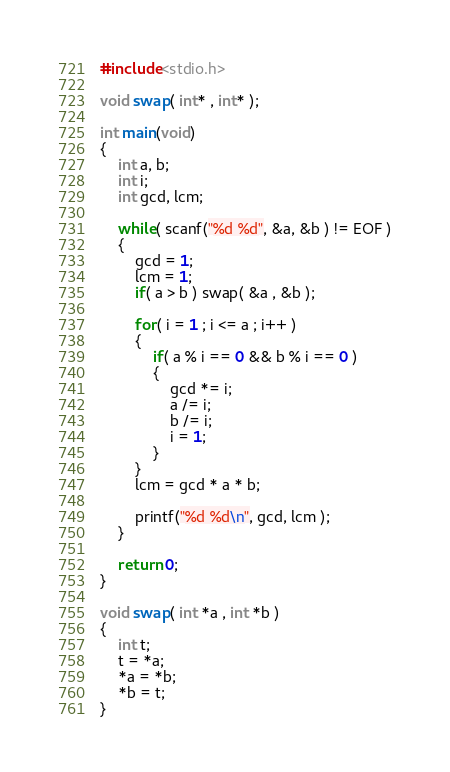<code> <loc_0><loc_0><loc_500><loc_500><_C_>#include<stdio.h>

void swap( int* , int* );

int main(void)
{
	int a, b;
	int i;
	int gcd, lcm;
	
	while( scanf("%d %d", &a, &b ) != EOF )
	{
		gcd = 1;
		lcm = 1;
		if( a > b ) swap( &a , &b );
	
		for( i = 1 ; i <= a ; i++ )
		{
			if( a % i == 0 && b % i == 0 )
			{
				gcd *= i;
				a /= i;
				b /= i;
				i = 1;
			}
		}
		lcm = gcd * a * b;

		printf("%d %d\n", gcd, lcm );
	}
	
	return 0;
}

void swap( int *a , int *b )
{
	int t;
	t = *a;
	*a = *b;
	*b = t;
}</code> 